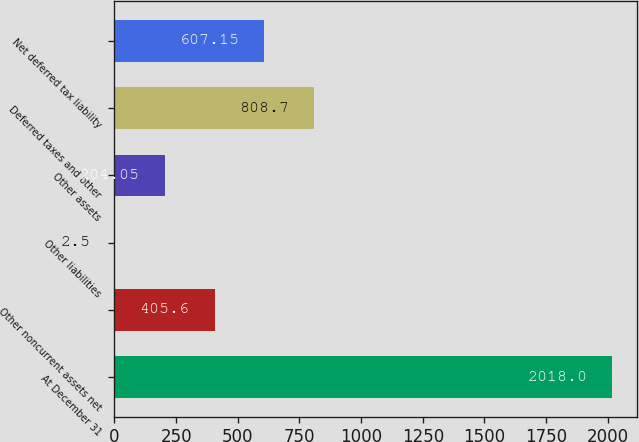<chart> <loc_0><loc_0><loc_500><loc_500><bar_chart><fcel>At December 31<fcel>Other noncurrent assets net<fcel>Other liabilities<fcel>Other assets<fcel>Deferred taxes and other<fcel>Net deferred tax liability<nl><fcel>2018<fcel>405.6<fcel>2.5<fcel>204.05<fcel>808.7<fcel>607.15<nl></chart> 